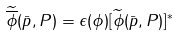Convert formula to latex. <formula><loc_0><loc_0><loc_500><loc_500>\widetilde { \overline { \phi } } ( \bar { p } , P ) = \epsilon ( \phi ) [ \widetilde { \phi } ( \bar { p } , P ) ] ^ { * }</formula> 